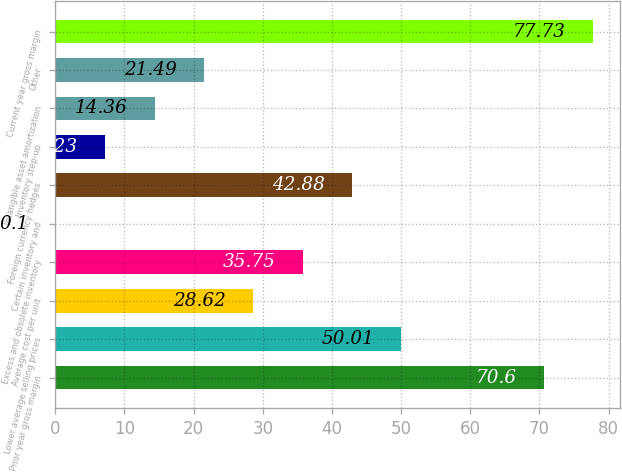Convert chart. <chart><loc_0><loc_0><loc_500><loc_500><bar_chart><fcel>Prior year gross margin<fcel>Lower average selling prices<fcel>Average cost per unit<fcel>Excess and obsolete inventory<fcel>Certain inventory and<fcel>Foreign currency hedges<fcel>Inventory step-up<fcel>Intangible asset amortization<fcel>Other<fcel>Current year gross margin<nl><fcel>70.6<fcel>50.01<fcel>28.62<fcel>35.75<fcel>0.1<fcel>42.88<fcel>7.23<fcel>14.36<fcel>21.49<fcel>77.73<nl></chart> 